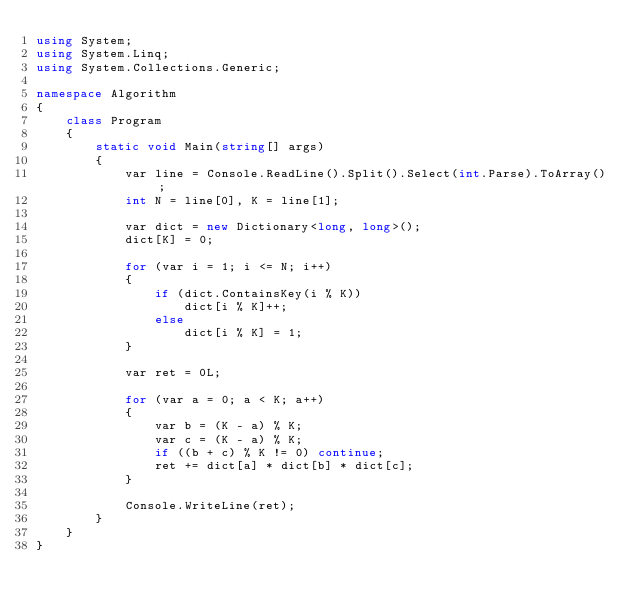<code> <loc_0><loc_0><loc_500><loc_500><_C#_>using System;
using System.Linq;
using System.Collections.Generic;

namespace Algorithm
{
    class Program
    {
        static void Main(string[] args)
        {
            var line = Console.ReadLine().Split().Select(int.Parse).ToArray();
            int N = line[0], K = line[1];

            var dict = new Dictionary<long, long>();
            dict[K] = 0;

            for (var i = 1; i <= N; i++)
            {
                if (dict.ContainsKey(i % K))
                    dict[i % K]++;
                else
                    dict[i % K] = 1;
            }

            var ret = 0L;

            for (var a = 0; a < K; a++)
            {
                var b = (K - a) % K;
                var c = (K - a) % K;
                if ((b + c) % K != 0) continue;
                ret += dict[a] * dict[b] * dict[c];
            }

            Console.WriteLine(ret);
        }
    }
}
</code> 